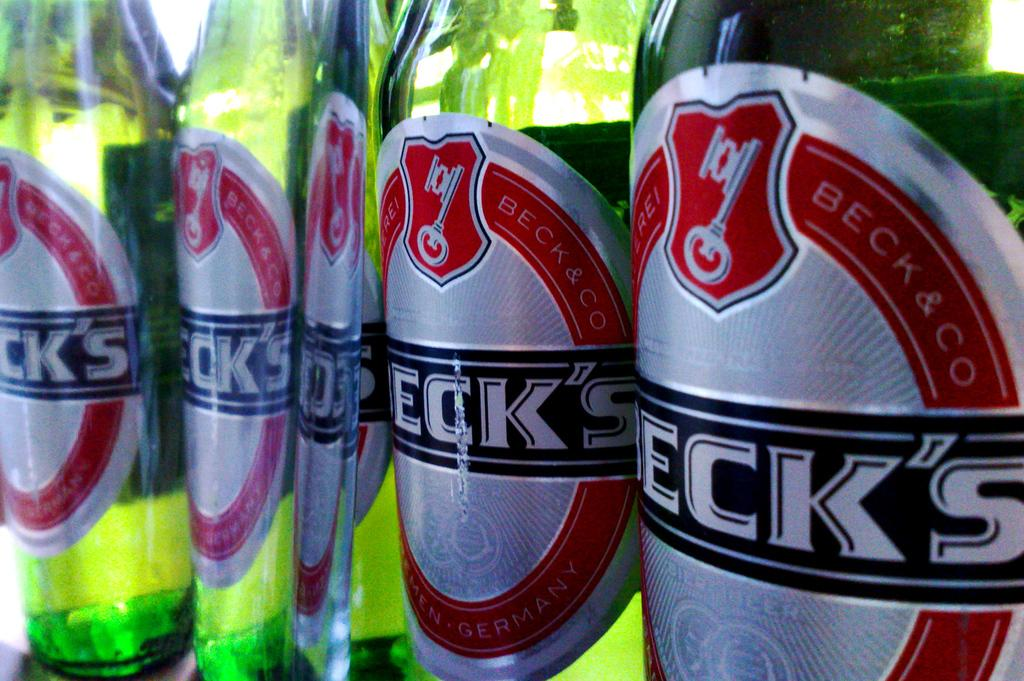<image>
Describe the image concisely. Bottles of Beck's are lined up together, side by side. 